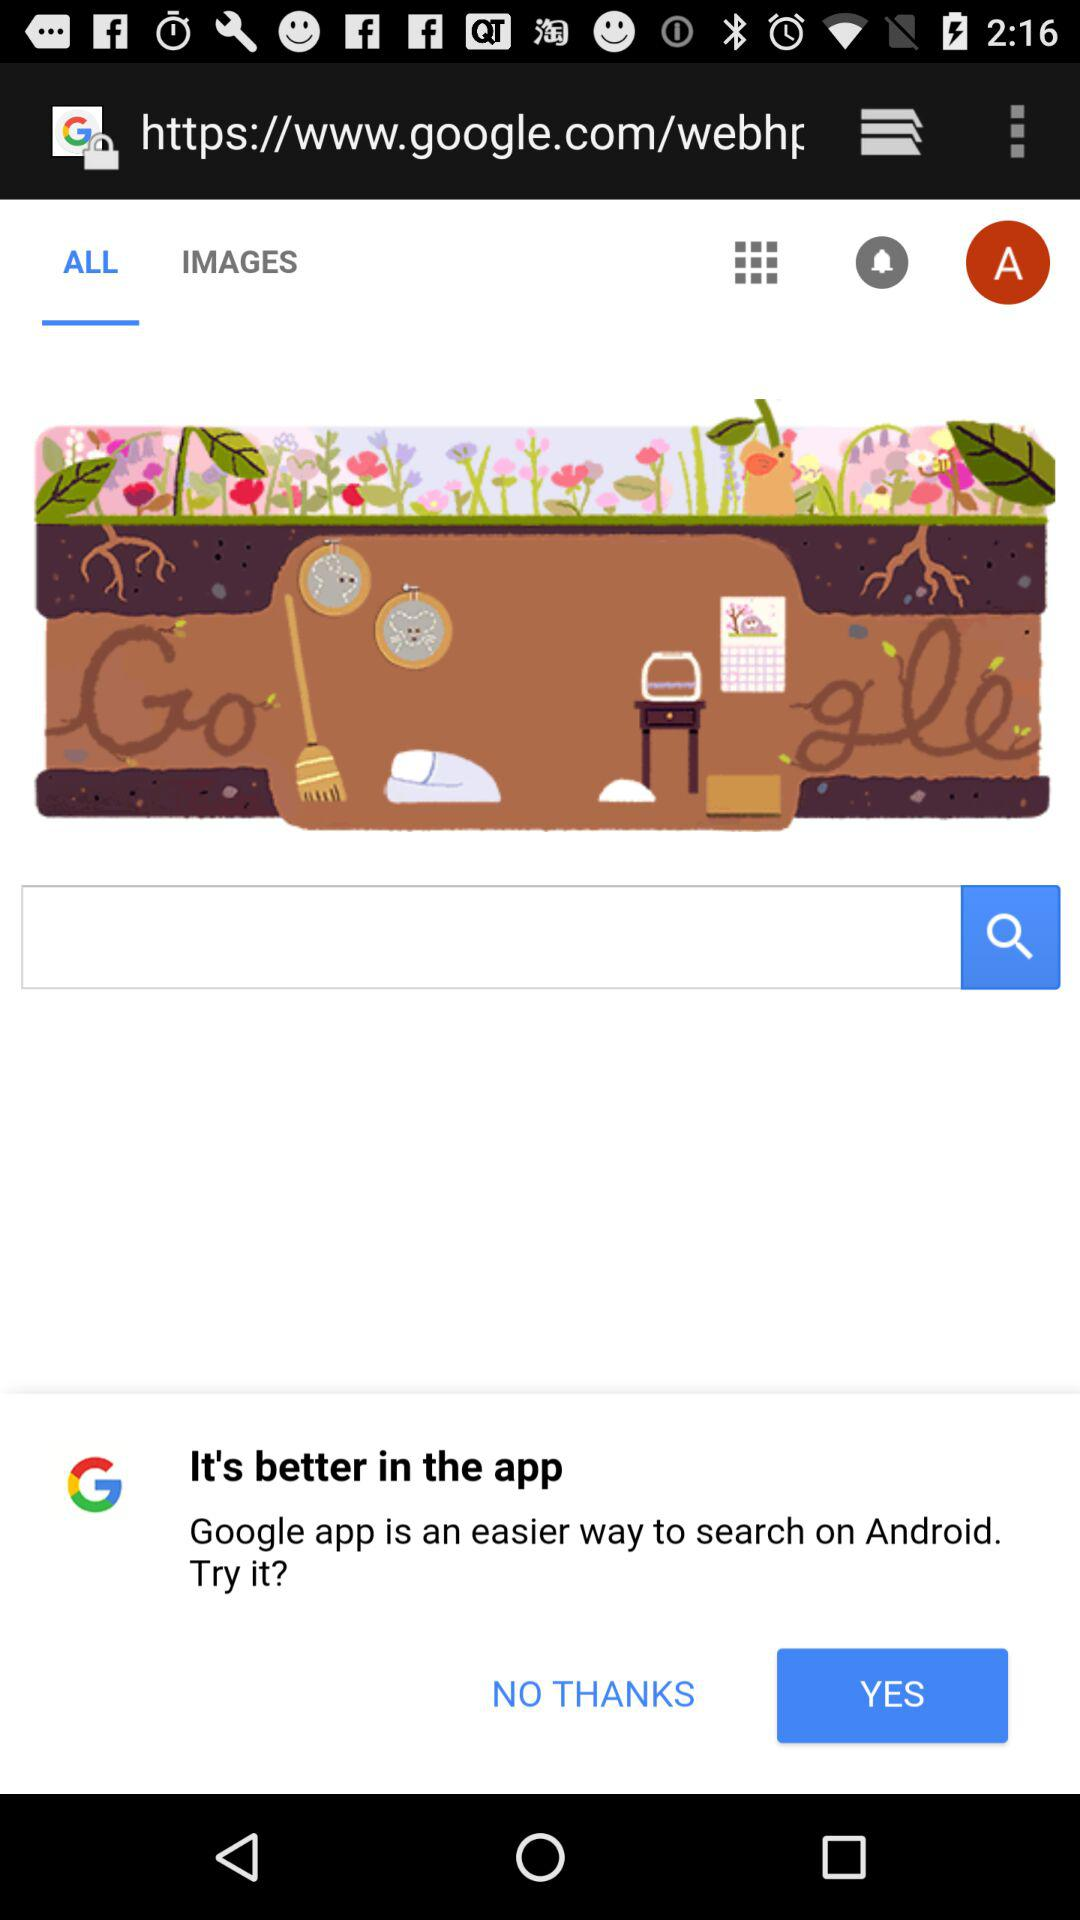Which tab is selected? The selected tab is "ALL". 